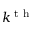Convert formula to latex. <formula><loc_0><loc_0><loc_500><loc_500>k ^ { t h }</formula> 